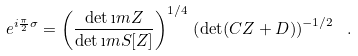Convert formula to latex. <formula><loc_0><loc_0><loc_500><loc_500>e ^ { i \frac { \pi } { 2 } \sigma } = \left ( \frac { \det \i m Z } { \det \i m S [ Z ] } \right ) ^ { 1 / 4 } \, \left ( \det ( C Z + D ) \right ) ^ { - 1 / 2 } \ .</formula> 